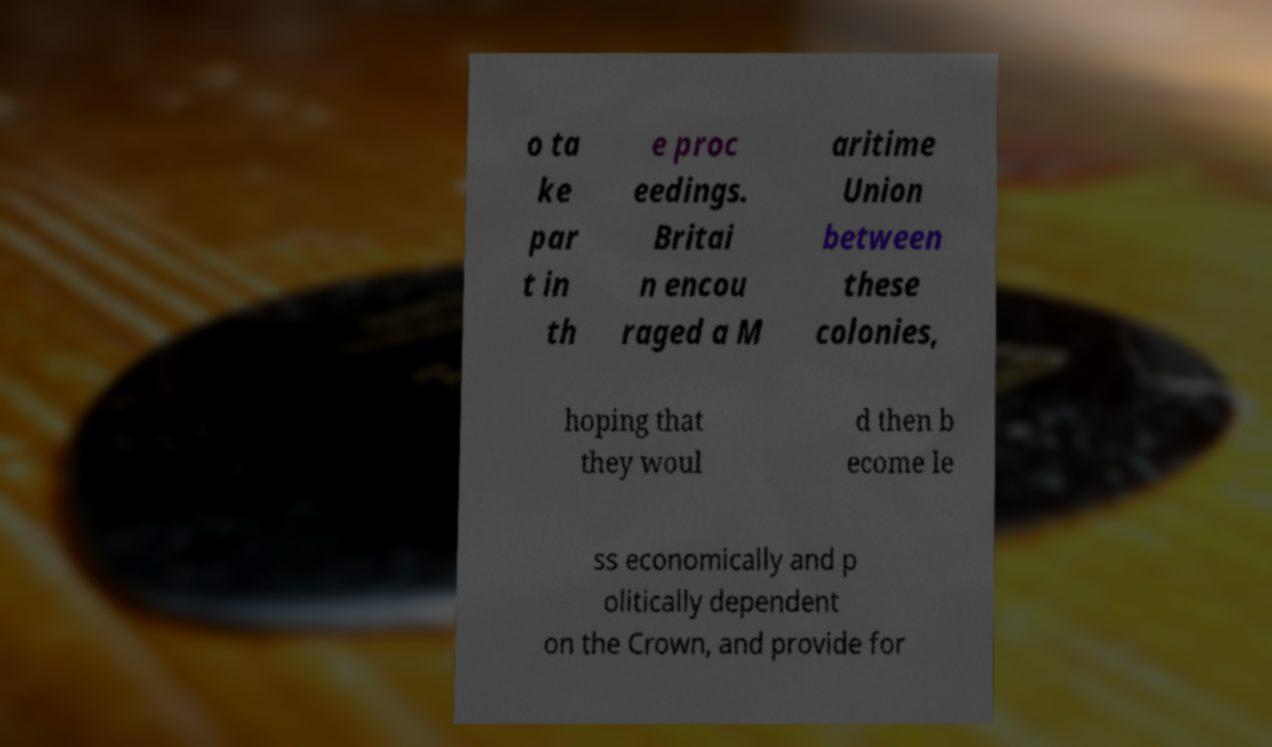Could you assist in decoding the text presented in this image and type it out clearly? o ta ke par t in th e proc eedings. Britai n encou raged a M aritime Union between these colonies, hoping that they woul d then b ecome le ss economically and p olitically dependent on the Crown, and provide for 